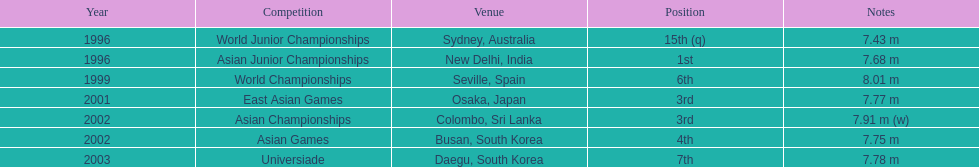How many instances did his leap exceed 5. 